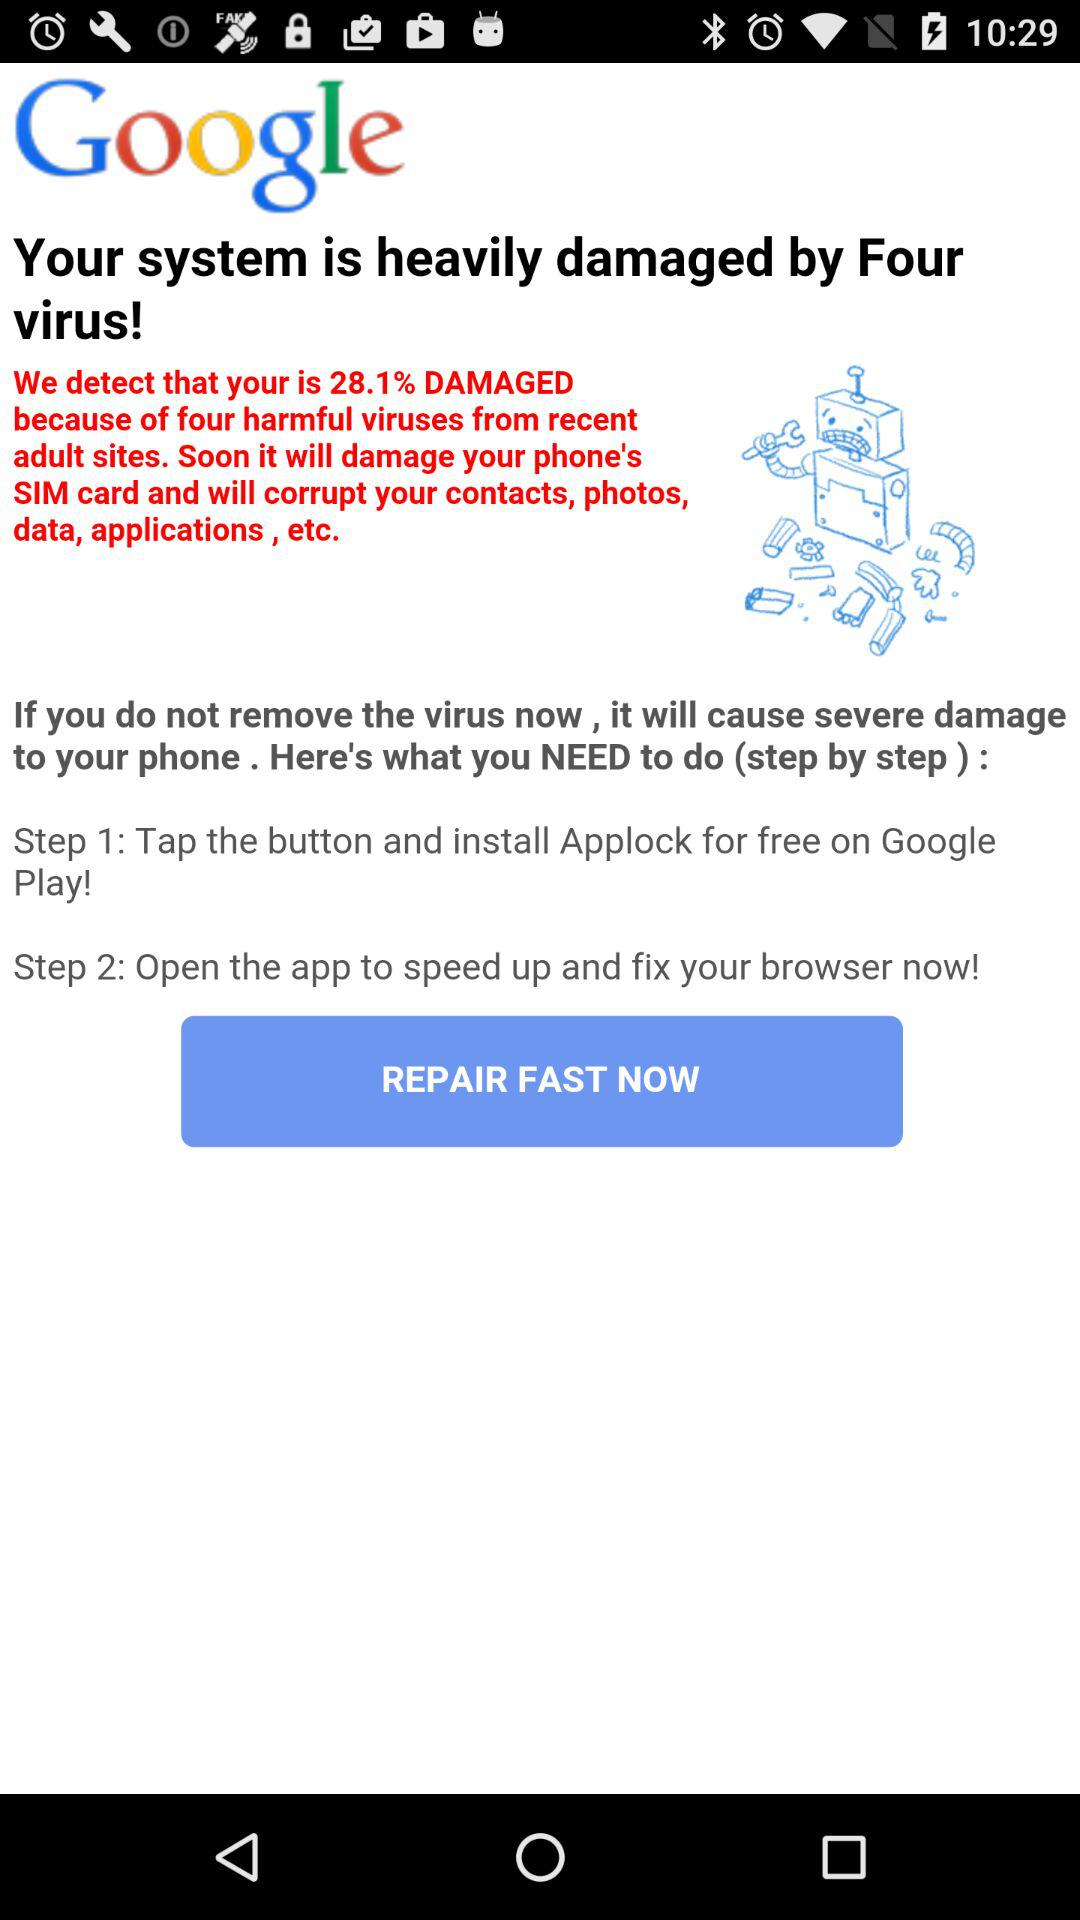How many viruses damaged the system? The number of viruses that damaged the system is four. 